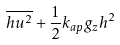Convert formula to latex. <formula><loc_0><loc_0><loc_500><loc_500>\overline { h u ^ { 2 } } + \frac { 1 } { 2 } k _ { a p } g _ { z } h ^ { 2 }</formula> 